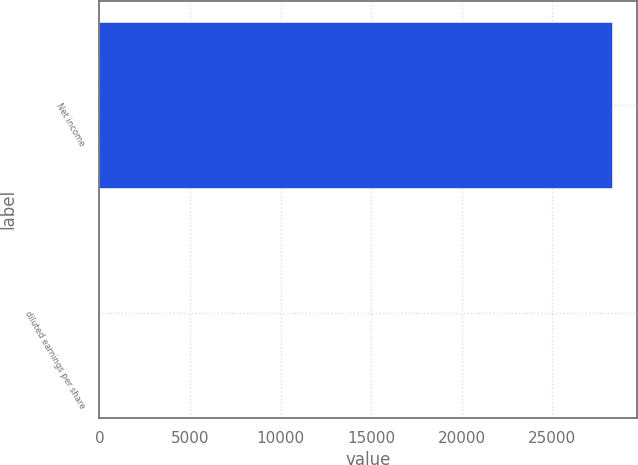<chart> <loc_0><loc_0><loc_500><loc_500><bar_chart><fcel>Net income<fcel>diluted earnings per share<nl><fcel>28293<fcel>0.4<nl></chart> 